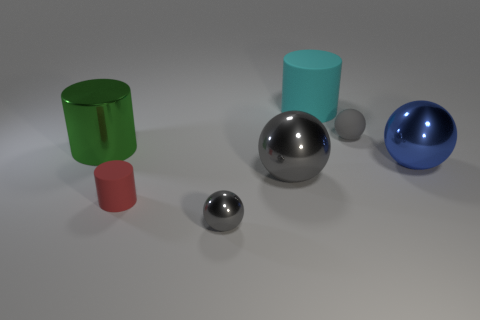What number of objects are small objects that are left of the tiny gray shiny thing or gray blocks?
Give a very brief answer. 1. Is there a gray shiny block?
Keep it short and to the point. No. There is a metallic thing that is both behind the tiny metallic object and to the left of the big gray shiny object; what shape is it?
Offer a very short reply. Cylinder. There is a gray sphere that is in front of the red cylinder; what size is it?
Offer a terse response. Small. Do the small object to the right of the big matte cylinder and the small metallic object have the same color?
Your response must be concise. Yes. What number of other matte objects have the same shape as the small red object?
Ensure brevity in your answer.  1. What number of things are either shiny spheres to the right of the tiny gray metallic object or large metal balls that are to the left of the gray rubber ball?
Keep it short and to the point. 2. What number of blue objects are either rubber objects or rubber spheres?
Offer a terse response. 0. What material is the cylinder that is both to the right of the big green metallic cylinder and behind the tiny red matte thing?
Make the answer very short. Rubber. Are the blue ball and the large green cylinder made of the same material?
Your answer should be very brief. Yes. 